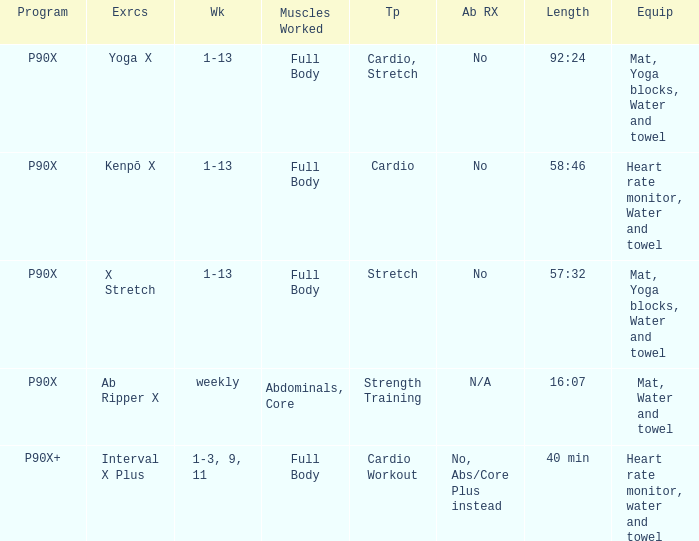What is the week when type is cardio workout? 1-3, 9, 11. 